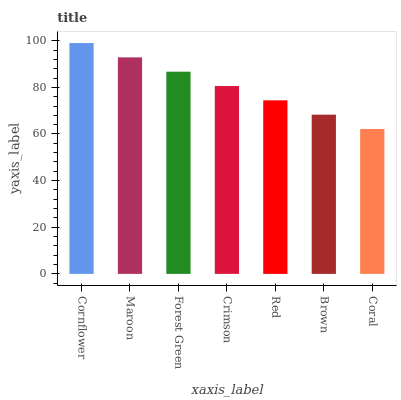Is Coral the minimum?
Answer yes or no. Yes. Is Cornflower the maximum?
Answer yes or no. Yes. Is Maroon the minimum?
Answer yes or no. No. Is Maroon the maximum?
Answer yes or no. No. Is Cornflower greater than Maroon?
Answer yes or no. Yes. Is Maroon less than Cornflower?
Answer yes or no. Yes. Is Maroon greater than Cornflower?
Answer yes or no. No. Is Cornflower less than Maroon?
Answer yes or no. No. Is Crimson the high median?
Answer yes or no. Yes. Is Crimson the low median?
Answer yes or no. Yes. Is Maroon the high median?
Answer yes or no. No. Is Forest Green the low median?
Answer yes or no. No. 